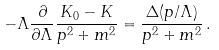<formula> <loc_0><loc_0><loc_500><loc_500>- \Lambda \frac { \partial } { \partial \Lambda } \frac { K _ { 0 } - K } { p ^ { 2 } + m ^ { 2 } } = \frac { \Delta ( p / \Lambda ) } { p ^ { 2 } + m ^ { 2 } } \, .</formula> 